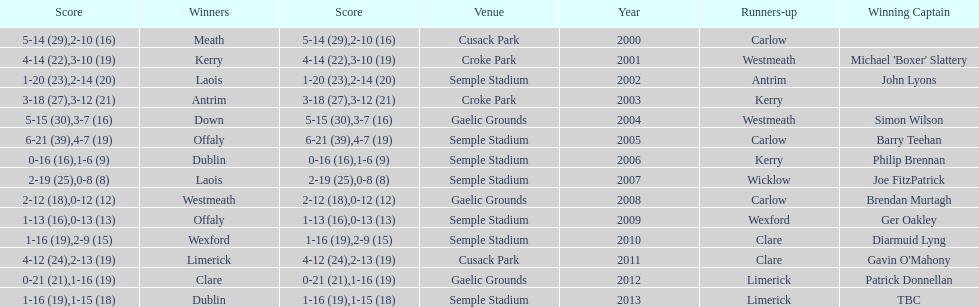After 2007, who was the champion? Laois. 